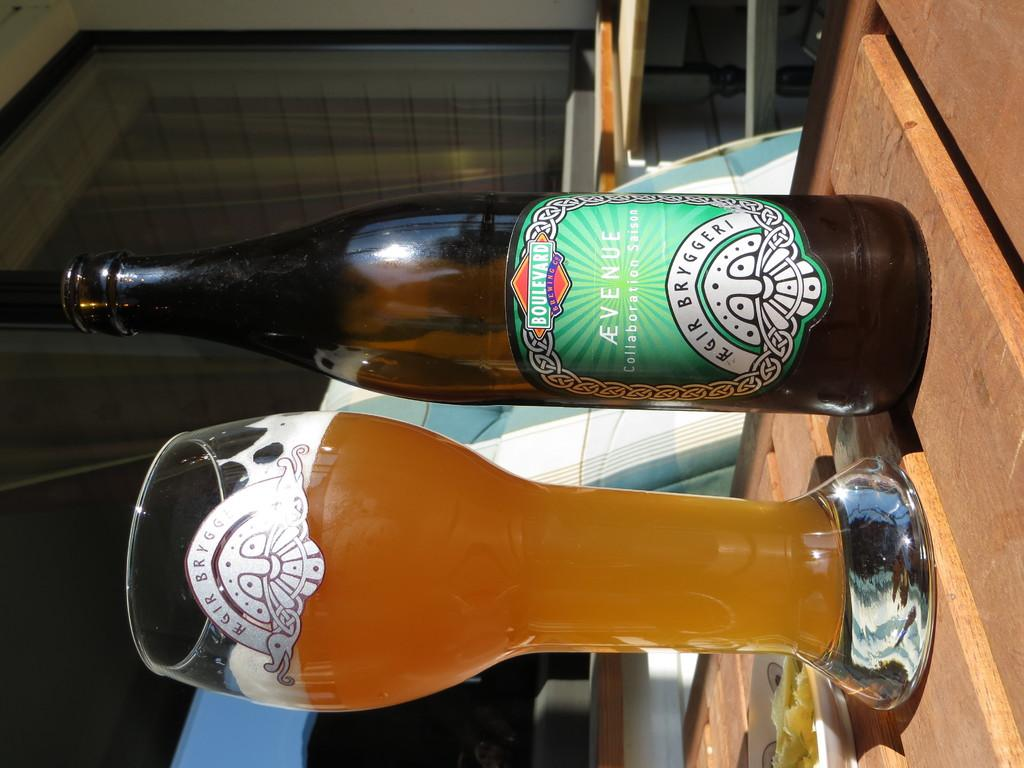Provide a one-sentence caption for the provided image. An Avenue beer bottle with a green label beside a beer glass filled with beer on a table top. 